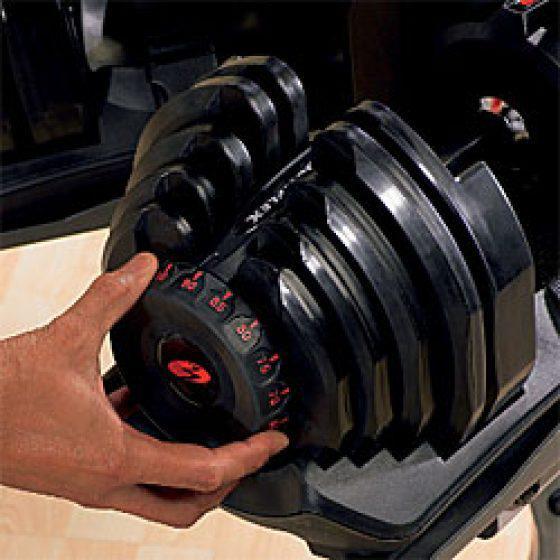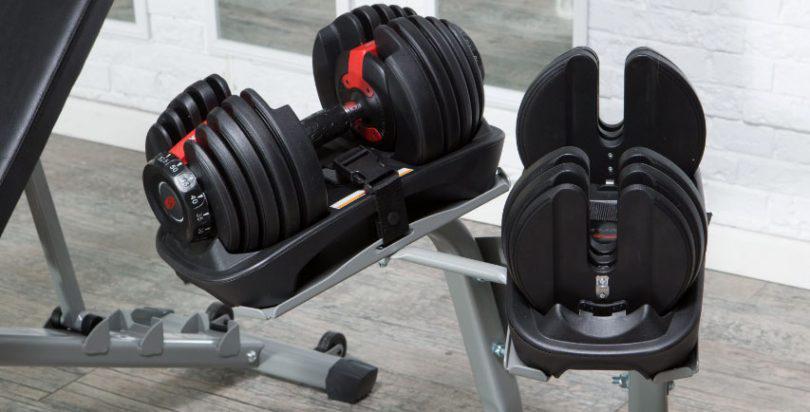The first image is the image on the left, the second image is the image on the right. Evaluate the accuracy of this statement regarding the images: "In at least one image there is a single hand adjusting a red and black weight.". Is it true? Answer yes or no. Yes. 